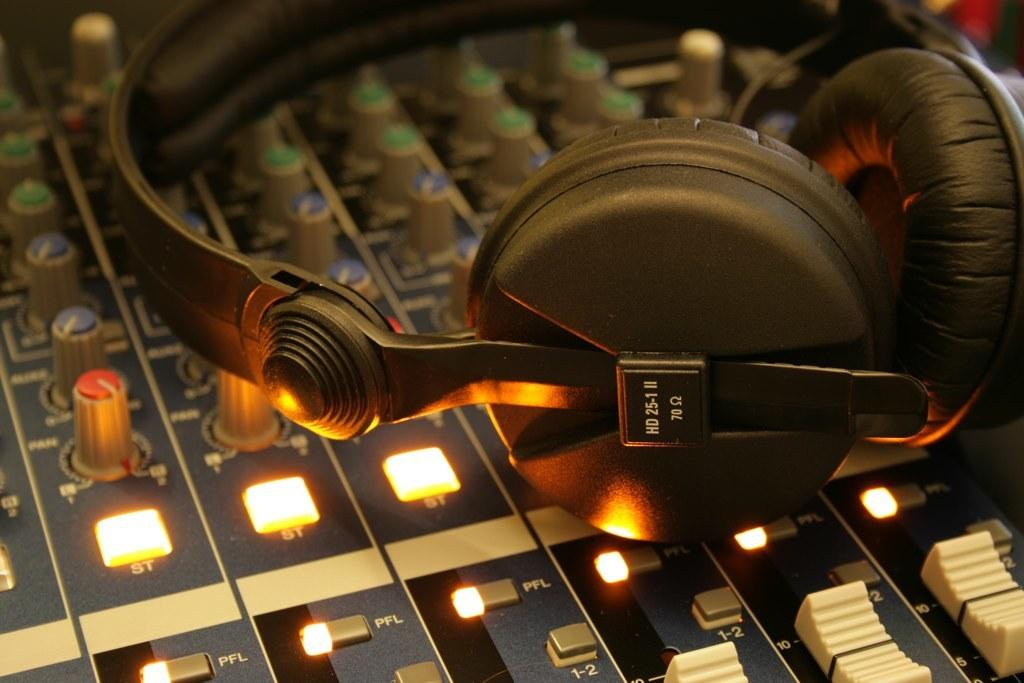What is located in the foreground of the image? There is a headset in the foreground of the image. What can be found at the bottom of the image? There are buttons at the bottom of the image. What type of illumination is present in the image? There are lights visible in the image. What type of farm animals can be seen grazing in the background of the image? There is no farm or animals present in the image; it features a headset and buttons with lights. 